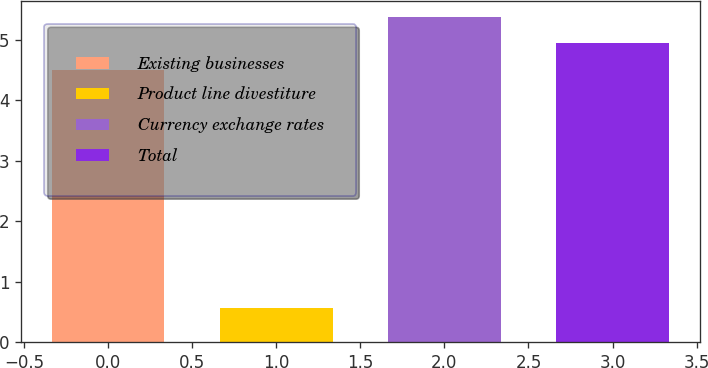Convert chart to OTSL. <chart><loc_0><loc_0><loc_500><loc_500><bar_chart><fcel>Existing businesses<fcel>Product line divestiture<fcel>Currency exchange rates<fcel>Total<nl><fcel>4.5<fcel>0.56<fcel>5.38<fcel>4.94<nl></chart> 